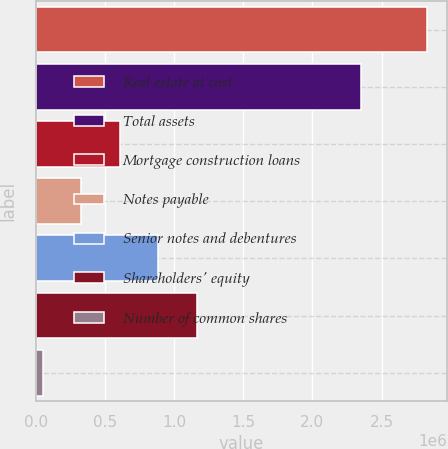Convert chart. <chart><loc_0><loc_0><loc_500><loc_500><bar_chart><fcel>Real estate at cost<fcel>Total assets<fcel>Mortgage construction loans<fcel>Notes payable<fcel>Senior notes and debentures<fcel>Shareholders' equity<fcel>Number of common shares<nl><fcel>2.82932e+06<fcel>2.35085e+06<fcel>608177<fcel>330534<fcel>885820<fcel>1.16346e+06<fcel>52891<nl></chart> 